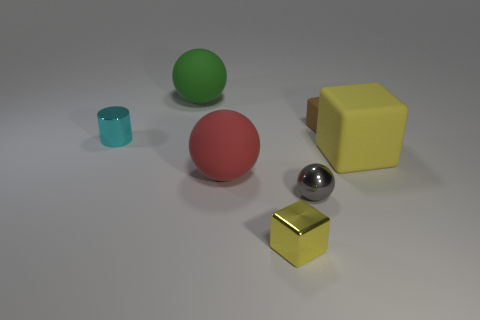Add 2 large red things. How many objects exist? 9 Subtract all balls. How many objects are left? 4 Subtract all small blocks. Subtract all large blocks. How many objects are left? 4 Add 4 big rubber balls. How many big rubber balls are left? 6 Add 7 brown things. How many brown things exist? 8 Subtract 0 blue spheres. How many objects are left? 7 